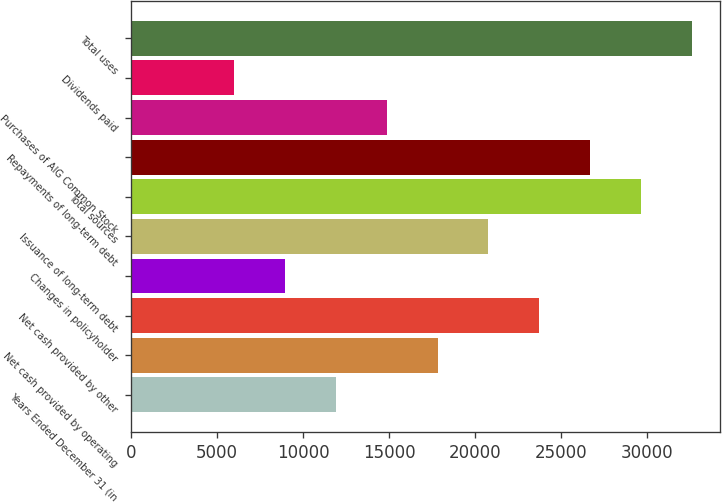Convert chart. <chart><loc_0><loc_0><loc_500><loc_500><bar_chart><fcel>Years Ended December 31 (in<fcel>Net cash provided by operating<fcel>Net cash provided by other<fcel>Changes in policyholder<fcel>Issuance of long-term debt<fcel>Total sources<fcel>Repayments of long-term debt<fcel>Purchases of AIG Common Stock<fcel>Dividends paid<fcel>Total uses<nl><fcel>11900.8<fcel>17814.2<fcel>23727.6<fcel>8944.1<fcel>20770.9<fcel>29641<fcel>26684.3<fcel>14857.5<fcel>5987.4<fcel>32597.7<nl></chart> 